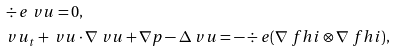<formula> <loc_0><loc_0><loc_500><loc_500>& \div e \ v u = 0 , \\ & \ v u _ { t } + \ v u \cdot \nabla \ v u + \nabla p - \Delta \ v u = - \div e ( \nabla \ f h i \otimes \nabla \ f h i ) ,</formula> 